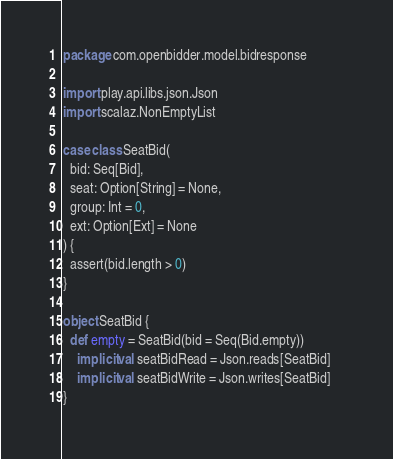<code> <loc_0><loc_0><loc_500><loc_500><_Scala_>package com.openbidder.model.bidresponse

import play.api.libs.json.Json
import scalaz.NonEmptyList

case class SeatBid(
  bid: Seq[Bid],
  seat: Option[String] = None,
  group: Int = 0,
  ext: Option[Ext] = None
) {
  assert(bid.length > 0)
}

object SeatBid {
  def empty = SeatBid(bid = Seq(Bid.empty))
	implicit val seatBidRead = Json.reads[SeatBid]
	implicit val seatBidWrite = Json.writes[SeatBid] 	
} </code> 